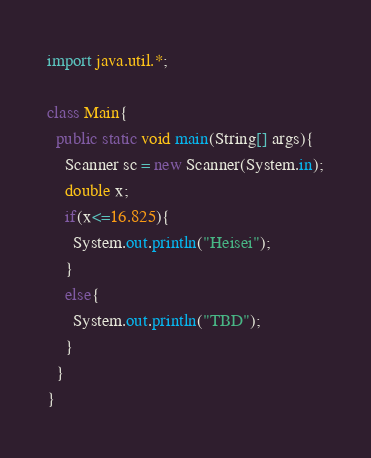Convert code to text. <code><loc_0><loc_0><loc_500><loc_500><_Java_>import java.util.*;

class Main{
  public static void main(String[] args){
    Scanner sc = new Scanner(System.in);
    double x;
    if(x<=16.825){
      System.out.println("Heisei");
    }
    else{
      System.out.println("TBD");
    }
  }
}</code> 